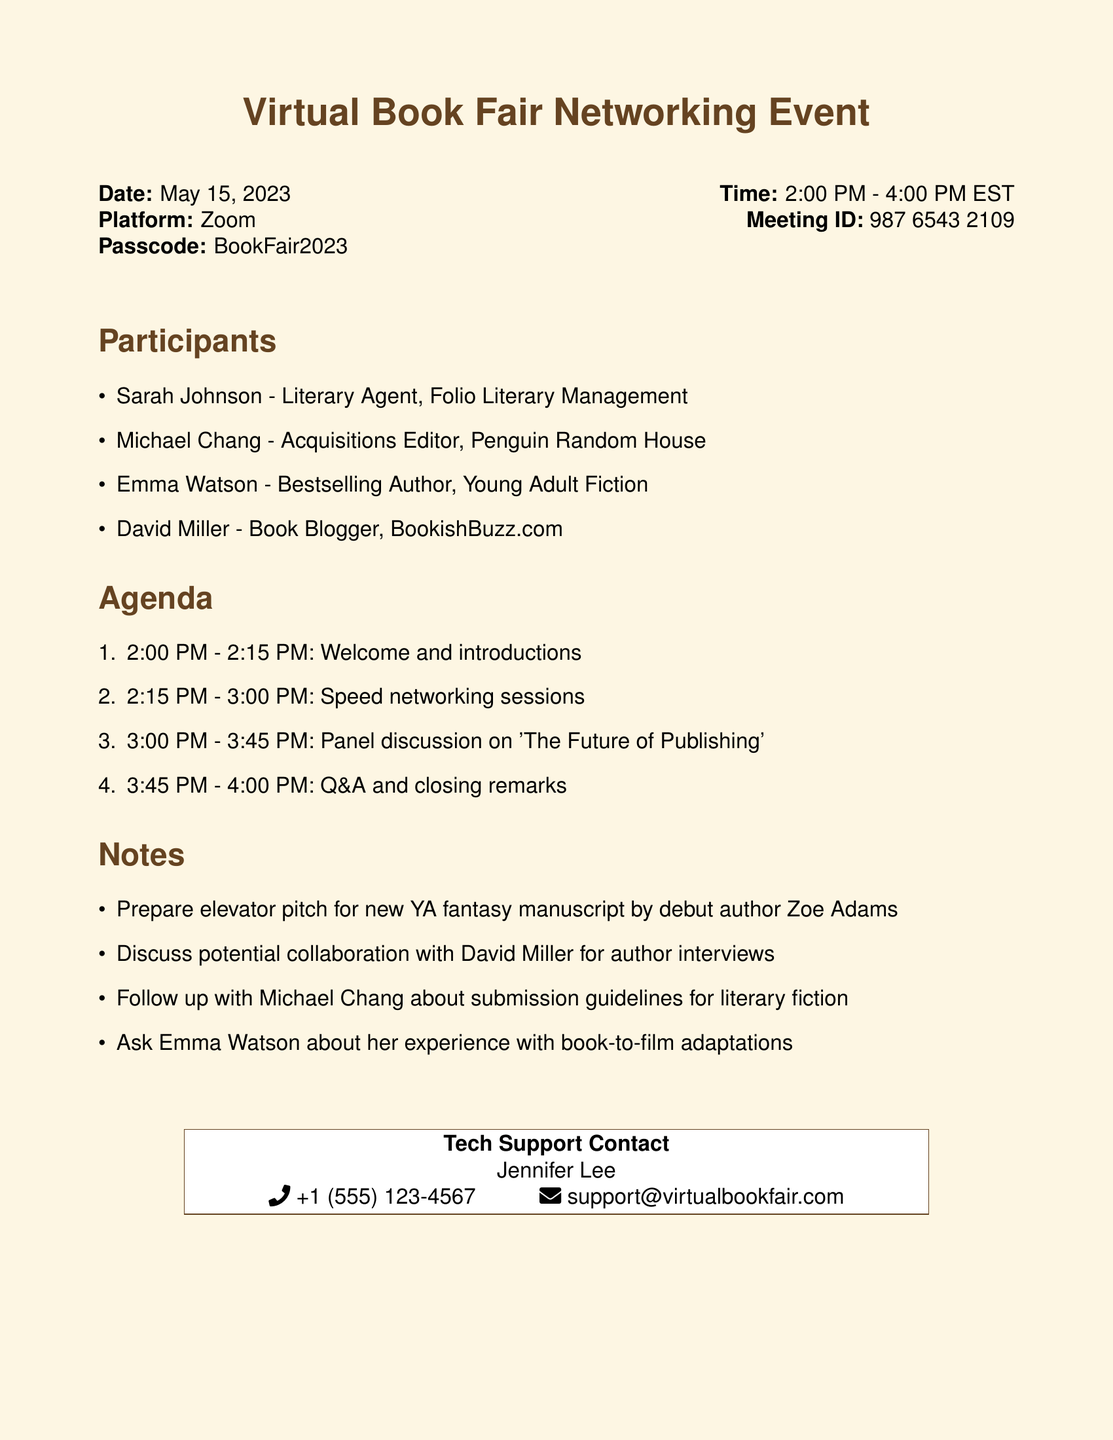What is the date of the event? The date of the event is clearly mentioned in the document under the event details.
Answer: May 15, 2023 What is the passcode for the meeting? The passcode is provided alongside the meeting ID in the document.
Answer: BookFair2023 Who is the tech support contact? The tech support contact is listed at the end of the document in the tech support section.
Answer: Jennifer Lee What time does the panel discussion start? The start time for the panel discussion is listed in the agenda section of the document.
Answer: 3:00 PM What type of session occurs from 2:15 PM to 3:00 PM? The agenda specifies the type of session occurring in that time slot.
Answer: Speed networking sessions How many participants are listed? The number of participants is found in the participants section of the document.
Answer: Four What is one agenda item that includes a Q&A session? The agenda includes a specific time frame for a Q&A, which signifies audience interaction.
Answer: Q&A and closing remarks Who is the bestselling author participating in the event? The document lists participating authors, making it clear who the bestselling author is.
Answer: Emma Watson What is the platform used for the event? The document explicitly states the platform used for the virtual event.
Answer: Zoom 